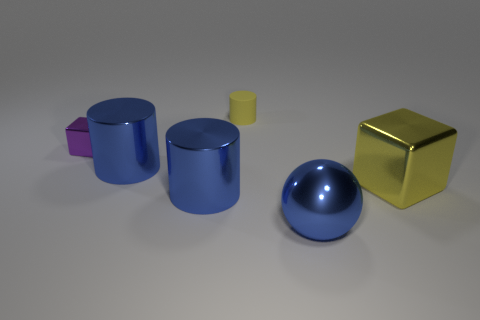Add 1 tiny purple metallic cubes. How many objects exist? 7 Subtract all yellow cylinders. How many cylinders are left? 2 Subtract all rubber cylinders. How many cylinders are left? 2 Subtract all blocks. How many objects are left? 4 Add 4 blue objects. How many blue objects are left? 7 Add 3 small red rubber spheres. How many small red rubber spheres exist? 3 Subtract 0 red spheres. How many objects are left? 6 Subtract 2 cylinders. How many cylinders are left? 1 Subtract all cyan cylinders. Subtract all red balls. How many cylinders are left? 3 Subtract all purple cylinders. How many purple blocks are left? 1 